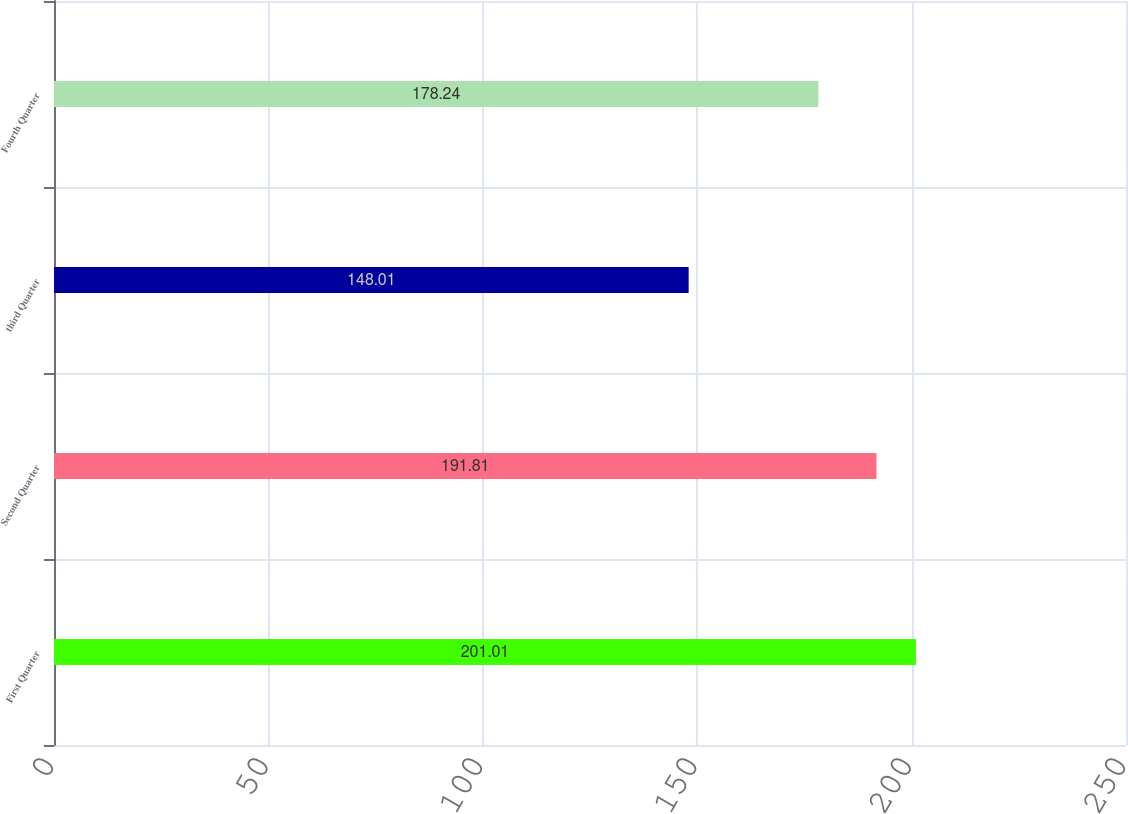Convert chart. <chart><loc_0><loc_0><loc_500><loc_500><bar_chart><fcel>First Quarter<fcel>Second Quarter<fcel>third Quarter<fcel>Fourth Quarter<nl><fcel>201.01<fcel>191.81<fcel>148.01<fcel>178.24<nl></chart> 